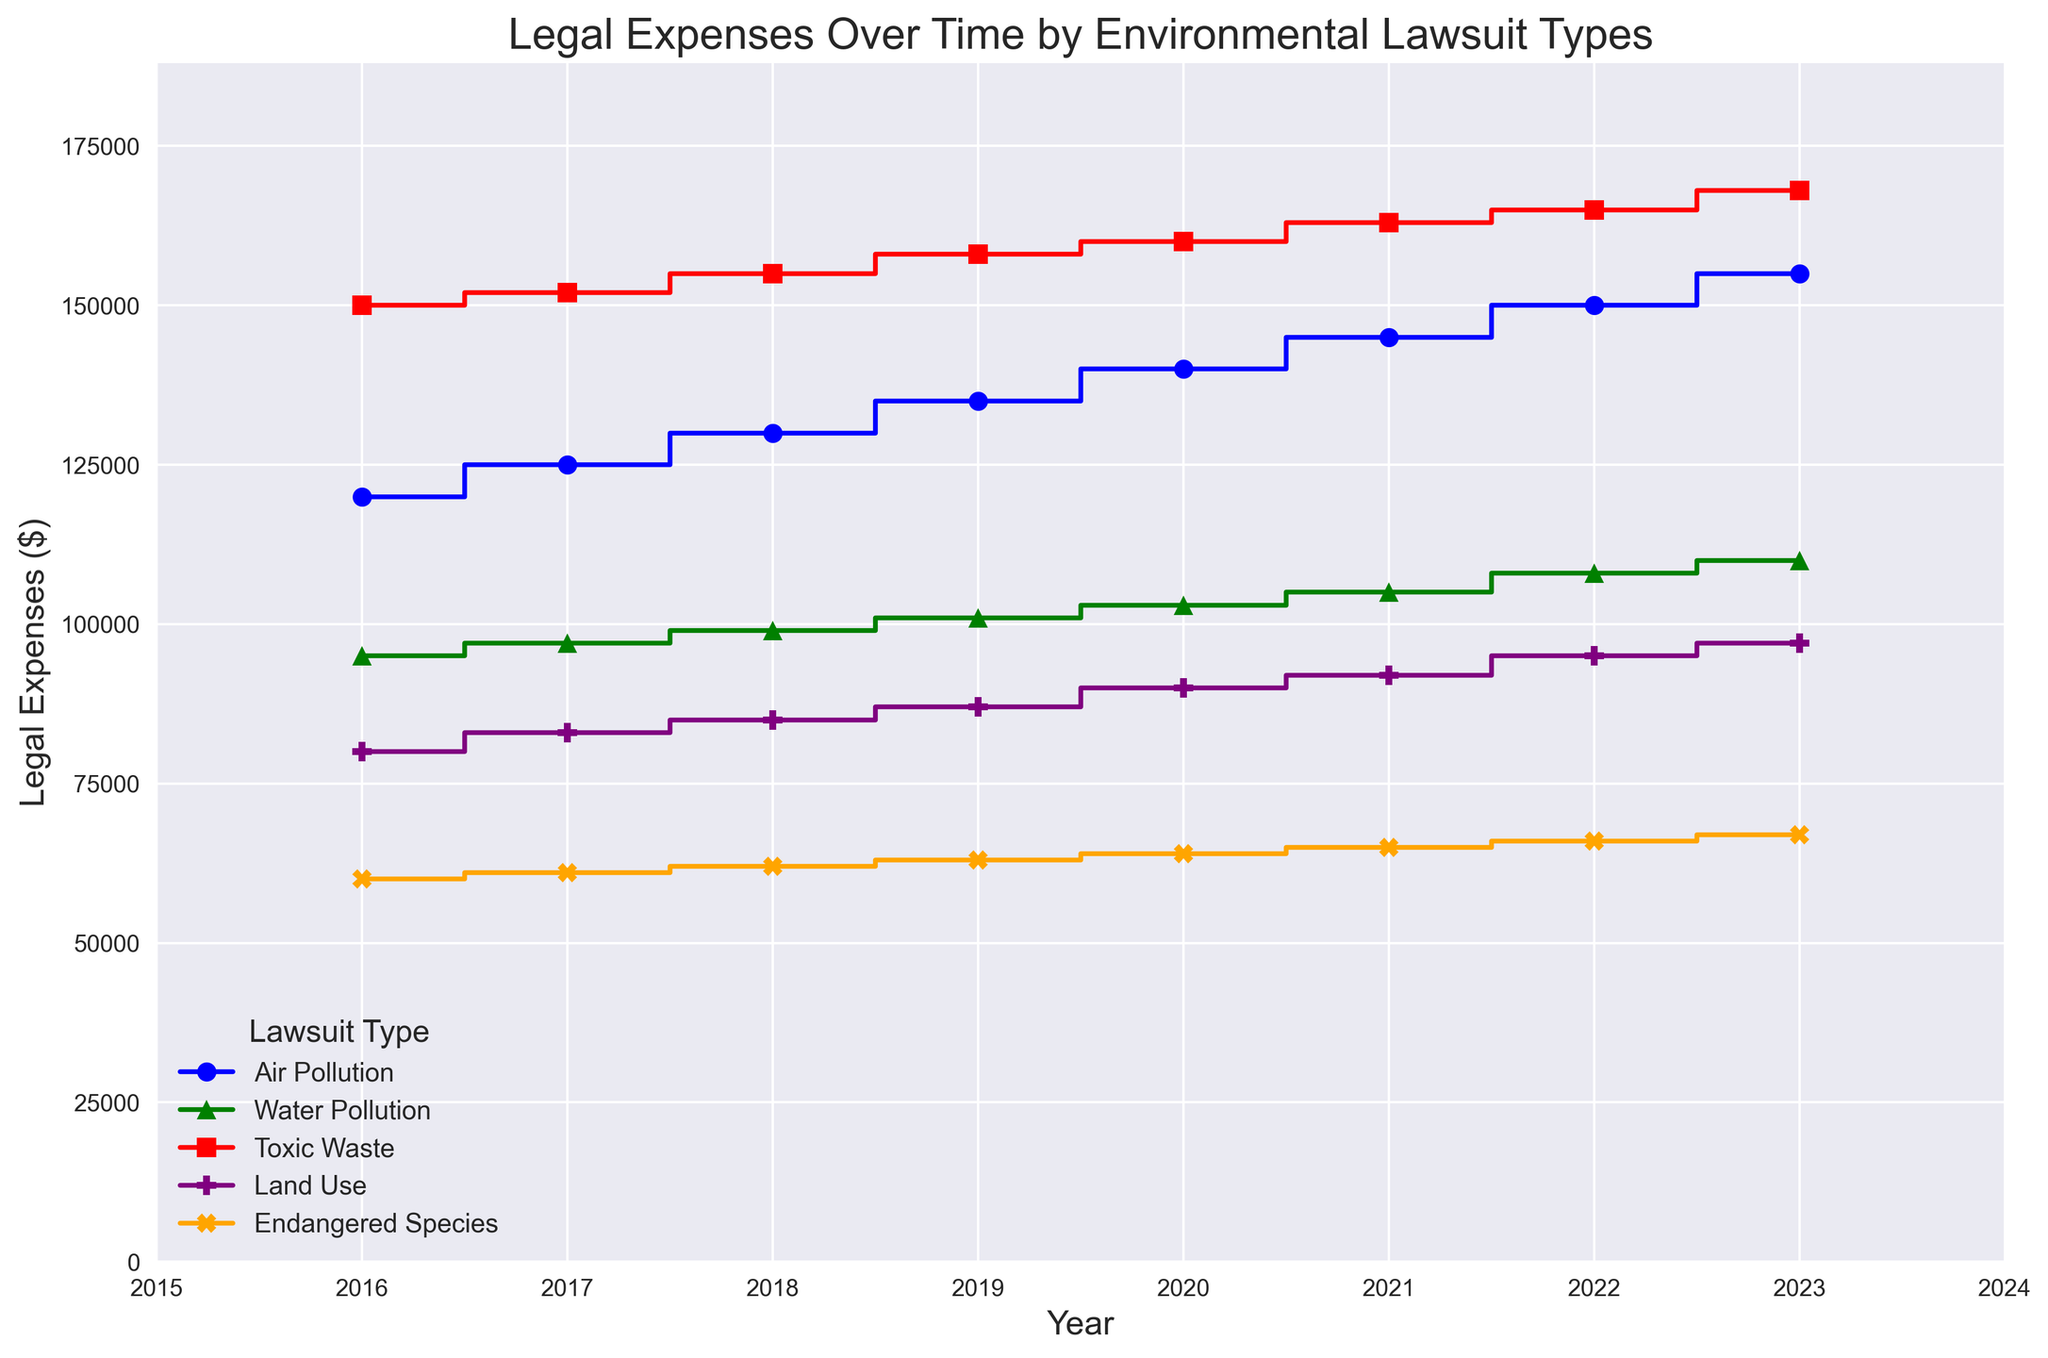What year had the highest legal expense for Toxic Waste lawsuits? Look at the stair steps for "Toxic Waste" marked in red and observe the highest point on the y-axis, which occurs in the year 2023.
Answer: 2023 Which lawsuit type had the lowest legal expenses in 2016? Compare the heights of the different steps in 2016. Notice "Endangered Species" marked in orange has the lowest value at 60,000.
Answer: Endangered Species What is the combined legal expense for Air Pollution and Water Pollution in 2020? Add the expenses for Air Pollution (140000) and Water Pollution (103000) in 2020. The combined value is 140000 + 103000 = 243000.
Answer: 243000 How much did the legal expenses for Land Use change from 2016 to 2023? Subtract the legal expense for Land Use in 2016 (80000) from that in 2023 (97000). The difference is 97000 - 80000 = 17000.
Answer: 17000 Between 2018 and 2019, which type of lawsuit saw the largest increase in legal expenses? Calculate the differences for each type: 
Air Pollution: 135000 - 130000 = 5000 
Water Pollution: 101000 - 99000 = 2000 
Toxic Waste: 158000 - 155000 = 3000 
Land Use: 87000 - 85000 = 2000 
Endangered Species: 63000 - 62000 = 1000 
The largest increase is for "Air Pollution" at 5000.
Answer: Air Pollution How does the total legal expense change from 2016 to 2023 for all lawsuit types combined? Sum the expenses for all types in 2016 and in 2023, then calculate the difference. 
2016 Total = 120000 + 95000 + 150000 + 80000 + 60000 = 505000 
2023 Total = 155000 + 110000 + 168000 + 97000 + 67000 = 597000 
Difference = 597000 - 505000 = 92000.
Answer: 92000 Which lawsuit type spent more in 2019: Air Pollution or Water Pollution? Compare their expenses in 2019. Air Pollution is 135000 and Water Pollution is 101000. Air Pollution has the higher expense.
Answer: Air Pollution What is the yearly average legal expense for Endangered Species lawsuits over all years? Sum the expenses for each year, then divide by the number of years. 
Sum = 60000 + 61000 + 62000 + 63000 + 64000 + 65000 + 66000 + 67000 =520000 
Average = 520000 / 8 = 65000.
Answer: 65000 